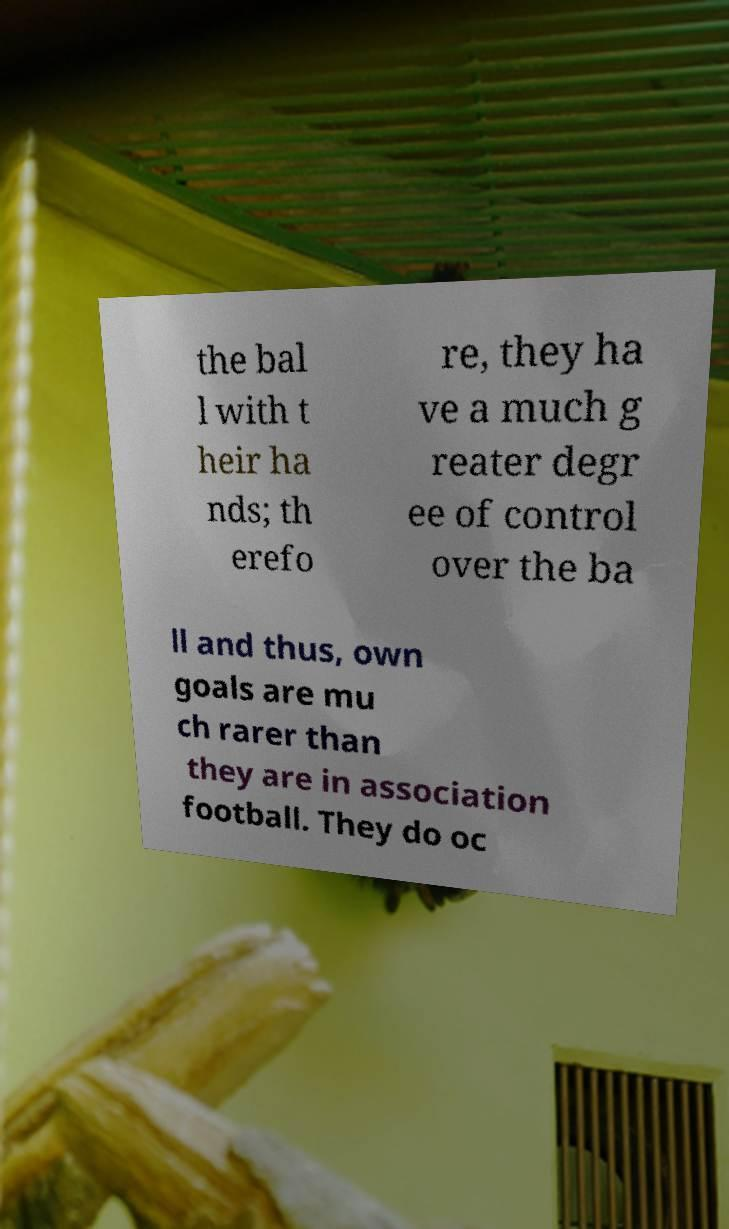Can you read and provide the text displayed in the image?This photo seems to have some interesting text. Can you extract and type it out for me? the bal l with t heir ha nds; th erefo re, they ha ve a much g reater degr ee of control over the ba ll and thus, own goals are mu ch rarer than they are in association football. They do oc 